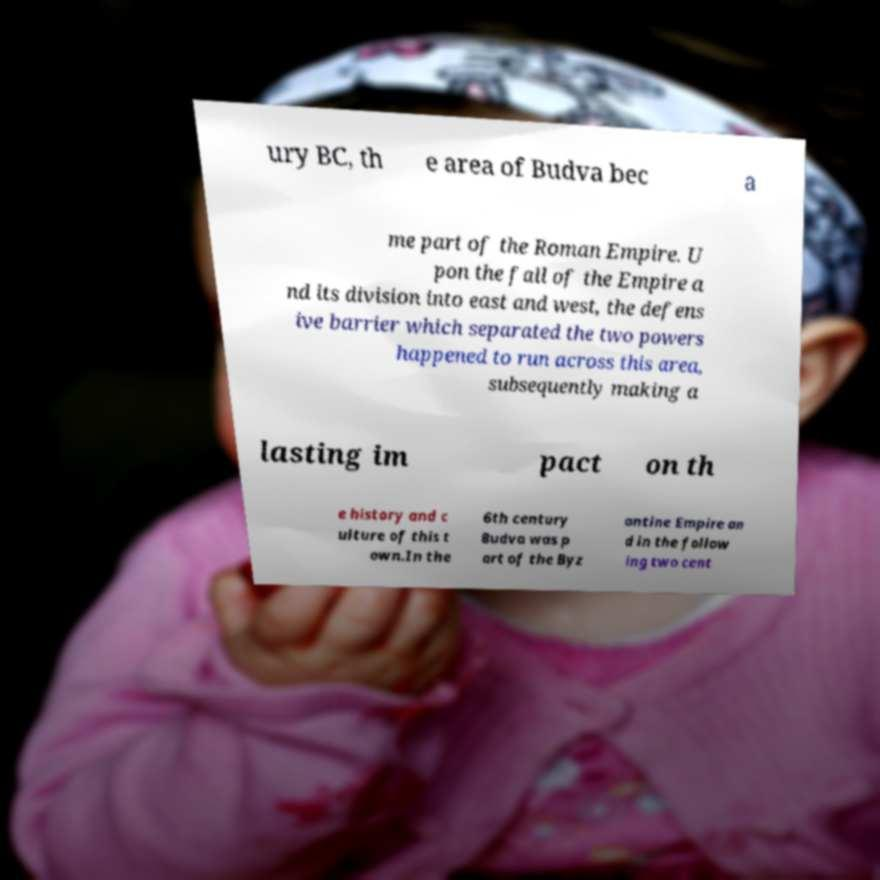Can you accurately transcribe the text from the provided image for me? ury BC, th e area of Budva bec a me part of the Roman Empire. U pon the fall of the Empire a nd its division into east and west, the defens ive barrier which separated the two powers happened to run across this area, subsequently making a lasting im pact on th e history and c ulture of this t own.In the 6th century Budva was p art of the Byz antine Empire an d in the follow ing two cent 